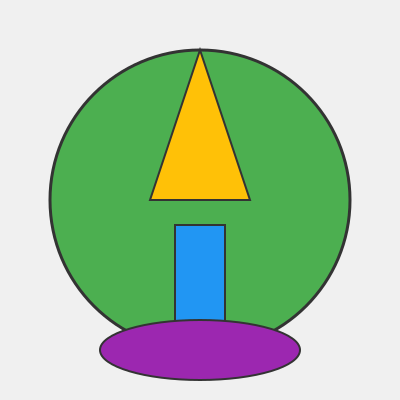Based on the stylized map illustration provided, which iconic MCU location is being represented? To identify the MCU location from this stylized map, let's break down the key elements:

1. The overall circular shape represents an isolated, self-contained area.
2. The triangular shape at the top resembles a mountain or peak.
3. The rectangular shape in the center could represent a tall building or structure.
4. The oval shape at the bottom might indicate a body of water or a specific landscape feature.

Considering these elements together, we can deduce that this illustration represents Wakanda, the fictional African nation from the MCU. Here's why:

1. The circular shape represents Wakanda's isolated and hidden nature.
2. The triangular peak likely represents Mount Bashenga, where vibranium is mined.
3. The rectangular structure in the center could be the Royal Palace or the Great Mound.
4. The oval shape at the bottom might represent the river that runs through the Golden City.

This stylized representation captures the essence of Wakanda's unique landscape and architectural elements as seen in films like "Black Panther" and "Avengers: Infinity War."
Answer: Wakanda 